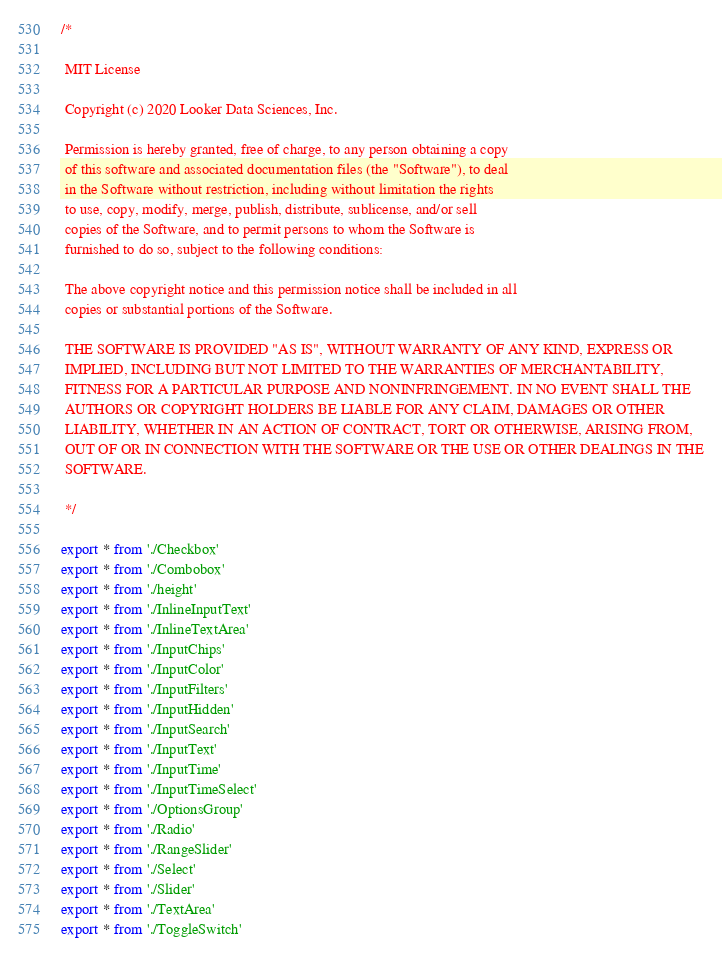Convert code to text. <code><loc_0><loc_0><loc_500><loc_500><_TypeScript_>/*

 MIT License

 Copyright (c) 2020 Looker Data Sciences, Inc.

 Permission is hereby granted, free of charge, to any person obtaining a copy
 of this software and associated documentation files (the "Software"), to deal
 in the Software without restriction, including without limitation the rights
 to use, copy, modify, merge, publish, distribute, sublicense, and/or sell
 copies of the Software, and to permit persons to whom the Software is
 furnished to do so, subject to the following conditions:

 The above copyright notice and this permission notice shall be included in all
 copies or substantial portions of the Software.

 THE SOFTWARE IS PROVIDED "AS IS", WITHOUT WARRANTY OF ANY KIND, EXPRESS OR
 IMPLIED, INCLUDING BUT NOT LIMITED TO THE WARRANTIES OF MERCHANTABILITY,
 FITNESS FOR A PARTICULAR PURPOSE AND NONINFRINGEMENT. IN NO EVENT SHALL THE
 AUTHORS OR COPYRIGHT HOLDERS BE LIABLE FOR ANY CLAIM, DAMAGES OR OTHER
 LIABILITY, WHETHER IN AN ACTION OF CONTRACT, TORT OR OTHERWISE, ARISING FROM,
 OUT OF OR IN CONNECTION WITH THE SOFTWARE OR THE USE OR OTHER DEALINGS IN THE
 SOFTWARE.

 */

export * from './Checkbox'
export * from './Combobox'
export * from './height'
export * from './InlineInputText'
export * from './InlineTextArea'
export * from './InputChips'
export * from './InputColor'
export * from './InputFilters'
export * from './InputHidden'
export * from './InputSearch'
export * from './InputText'
export * from './InputTime'
export * from './InputTimeSelect'
export * from './OptionsGroup'
export * from './Radio'
export * from './RangeSlider'
export * from './Select'
export * from './Slider'
export * from './TextArea'
export * from './ToggleSwitch'
</code> 